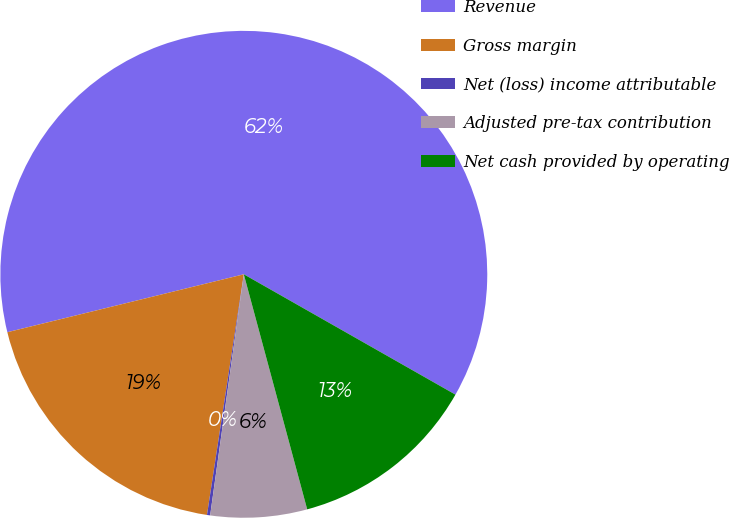<chart> <loc_0><loc_0><loc_500><loc_500><pie_chart><fcel>Revenue<fcel>Gross margin<fcel>Net (loss) income attributable<fcel>Adjusted pre-tax contribution<fcel>Net cash provided by operating<nl><fcel>62.05%<fcel>18.76%<fcel>0.21%<fcel>6.4%<fcel>12.58%<nl></chart> 